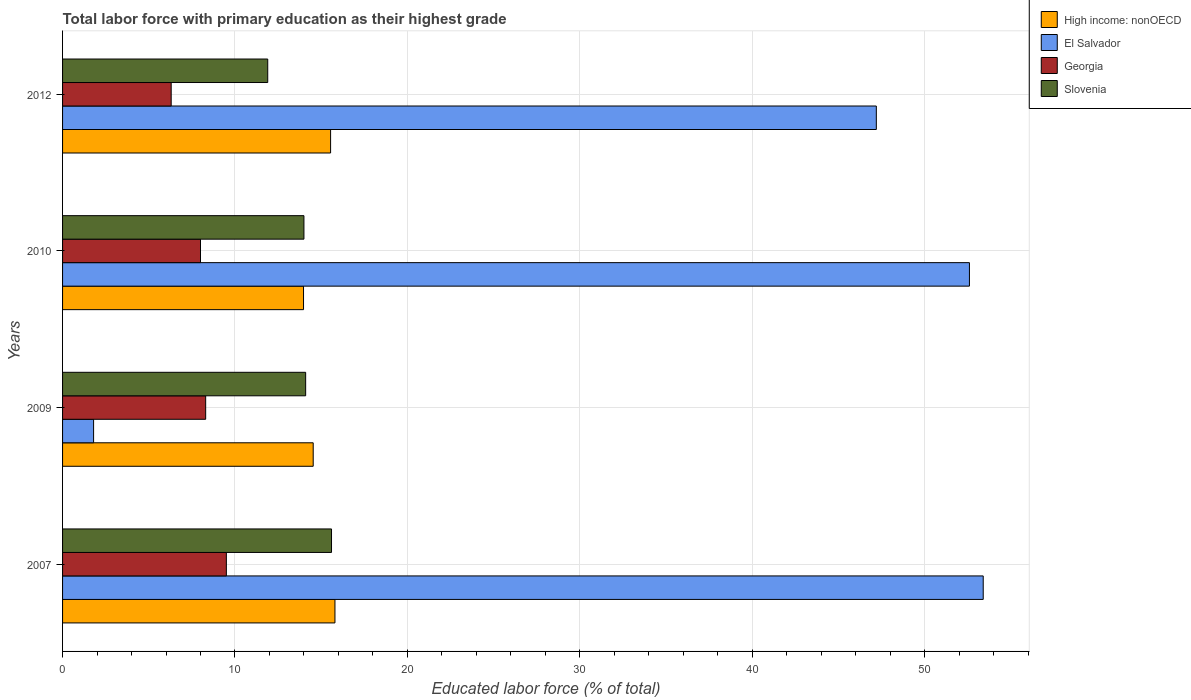How many groups of bars are there?
Provide a succinct answer. 4. Are the number of bars per tick equal to the number of legend labels?
Make the answer very short. Yes. How many bars are there on the 2nd tick from the top?
Offer a very short reply. 4. How many bars are there on the 3rd tick from the bottom?
Ensure brevity in your answer.  4. What is the label of the 4th group of bars from the top?
Ensure brevity in your answer.  2007. In how many cases, is the number of bars for a given year not equal to the number of legend labels?
Provide a short and direct response. 0. What is the percentage of total labor force with primary education in El Salvador in 2010?
Ensure brevity in your answer.  52.6. Across all years, what is the maximum percentage of total labor force with primary education in Slovenia?
Your response must be concise. 15.6. Across all years, what is the minimum percentage of total labor force with primary education in El Salvador?
Your answer should be very brief. 1.8. In which year was the percentage of total labor force with primary education in El Salvador minimum?
Make the answer very short. 2009. What is the total percentage of total labor force with primary education in Slovenia in the graph?
Your answer should be very brief. 55.6. What is the difference between the percentage of total labor force with primary education in High income: nonOECD in 2009 and that in 2010?
Make the answer very short. 0.56. What is the difference between the percentage of total labor force with primary education in High income: nonOECD in 2010 and the percentage of total labor force with primary education in Georgia in 2007?
Give a very brief answer. 4.48. What is the average percentage of total labor force with primary education in Slovenia per year?
Provide a short and direct response. 13.9. In the year 2009, what is the difference between the percentage of total labor force with primary education in Georgia and percentage of total labor force with primary education in El Salvador?
Keep it short and to the point. 6.5. What is the ratio of the percentage of total labor force with primary education in El Salvador in 2009 to that in 2010?
Provide a short and direct response. 0.03. Is the percentage of total labor force with primary education in Georgia in 2010 less than that in 2012?
Your answer should be compact. No. What is the difference between the highest and the second highest percentage of total labor force with primary education in High income: nonOECD?
Your answer should be compact. 0.25. What is the difference between the highest and the lowest percentage of total labor force with primary education in El Salvador?
Provide a short and direct response. 51.6. In how many years, is the percentage of total labor force with primary education in High income: nonOECD greater than the average percentage of total labor force with primary education in High income: nonOECD taken over all years?
Keep it short and to the point. 2. Is it the case that in every year, the sum of the percentage of total labor force with primary education in Slovenia and percentage of total labor force with primary education in Georgia is greater than the sum of percentage of total labor force with primary education in El Salvador and percentage of total labor force with primary education in High income: nonOECD?
Offer a very short reply. No. What does the 3rd bar from the top in 2007 represents?
Your answer should be compact. El Salvador. What does the 4th bar from the bottom in 2012 represents?
Your response must be concise. Slovenia. How many bars are there?
Provide a short and direct response. 16. Are all the bars in the graph horizontal?
Make the answer very short. Yes. Are the values on the major ticks of X-axis written in scientific E-notation?
Provide a succinct answer. No. Where does the legend appear in the graph?
Offer a terse response. Top right. How many legend labels are there?
Make the answer very short. 4. What is the title of the graph?
Your answer should be very brief. Total labor force with primary education as their highest grade. Does "Slovak Republic" appear as one of the legend labels in the graph?
Give a very brief answer. No. What is the label or title of the X-axis?
Your answer should be very brief. Educated labor force (% of total). What is the label or title of the Y-axis?
Offer a terse response. Years. What is the Educated labor force (% of total) in High income: nonOECD in 2007?
Your response must be concise. 15.8. What is the Educated labor force (% of total) in El Salvador in 2007?
Offer a terse response. 53.4. What is the Educated labor force (% of total) of Slovenia in 2007?
Ensure brevity in your answer.  15.6. What is the Educated labor force (% of total) of High income: nonOECD in 2009?
Your answer should be very brief. 14.54. What is the Educated labor force (% of total) in El Salvador in 2009?
Ensure brevity in your answer.  1.8. What is the Educated labor force (% of total) of Georgia in 2009?
Provide a short and direct response. 8.3. What is the Educated labor force (% of total) in Slovenia in 2009?
Keep it short and to the point. 14.1. What is the Educated labor force (% of total) of High income: nonOECD in 2010?
Ensure brevity in your answer.  13.98. What is the Educated labor force (% of total) in El Salvador in 2010?
Offer a terse response. 52.6. What is the Educated labor force (% of total) in Georgia in 2010?
Provide a short and direct response. 8. What is the Educated labor force (% of total) of High income: nonOECD in 2012?
Provide a succinct answer. 15.55. What is the Educated labor force (% of total) in El Salvador in 2012?
Ensure brevity in your answer.  47.2. What is the Educated labor force (% of total) of Georgia in 2012?
Offer a terse response. 6.3. What is the Educated labor force (% of total) in Slovenia in 2012?
Provide a succinct answer. 11.9. Across all years, what is the maximum Educated labor force (% of total) of High income: nonOECD?
Make the answer very short. 15.8. Across all years, what is the maximum Educated labor force (% of total) in El Salvador?
Your answer should be very brief. 53.4. Across all years, what is the maximum Educated labor force (% of total) of Slovenia?
Keep it short and to the point. 15.6. Across all years, what is the minimum Educated labor force (% of total) in High income: nonOECD?
Offer a very short reply. 13.98. Across all years, what is the minimum Educated labor force (% of total) in El Salvador?
Offer a very short reply. 1.8. Across all years, what is the minimum Educated labor force (% of total) in Georgia?
Provide a succinct answer. 6.3. Across all years, what is the minimum Educated labor force (% of total) of Slovenia?
Give a very brief answer. 11.9. What is the total Educated labor force (% of total) in High income: nonOECD in the graph?
Your answer should be very brief. 59.86. What is the total Educated labor force (% of total) in El Salvador in the graph?
Offer a terse response. 155. What is the total Educated labor force (% of total) of Georgia in the graph?
Provide a short and direct response. 32.1. What is the total Educated labor force (% of total) in Slovenia in the graph?
Give a very brief answer. 55.6. What is the difference between the Educated labor force (% of total) of High income: nonOECD in 2007 and that in 2009?
Provide a short and direct response. 1.26. What is the difference between the Educated labor force (% of total) in El Salvador in 2007 and that in 2009?
Provide a short and direct response. 51.6. What is the difference between the Educated labor force (% of total) in Slovenia in 2007 and that in 2009?
Ensure brevity in your answer.  1.5. What is the difference between the Educated labor force (% of total) of High income: nonOECD in 2007 and that in 2010?
Your answer should be very brief. 1.82. What is the difference between the Educated labor force (% of total) in Slovenia in 2007 and that in 2010?
Your answer should be very brief. 1.6. What is the difference between the Educated labor force (% of total) of High income: nonOECD in 2007 and that in 2012?
Ensure brevity in your answer.  0.25. What is the difference between the Educated labor force (% of total) in El Salvador in 2007 and that in 2012?
Keep it short and to the point. 6.2. What is the difference between the Educated labor force (% of total) of High income: nonOECD in 2009 and that in 2010?
Ensure brevity in your answer.  0.56. What is the difference between the Educated labor force (% of total) of El Salvador in 2009 and that in 2010?
Offer a very short reply. -50.8. What is the difference between the Educated labor force (% of total) of High income: nonOECD in 2009 and that in 2012?
Make the answer very short. -1.01. What is the difference between the Educated labor force (% of total) of El Salvador in 2009 and that in 2012?
Your answer should be compact. -45.4. What is the difference between the Educated labor force (% of total) in Georgia in 2009 and that in 2012?
Your answer should be compact. 2. What is the difference between the Educated labor force (% of total) of Slovenia in 2009 and that in 2012?
Give a very brief answer. 2.2. What is the difference between the Educated labor force (% of total) in High income: nonOECD in 2010 and that in 2012?
Offer a terse response. -1.57. What is the difference between the Educated labor force (% of total) of High income: nonOECD in 2007 and the Educated labor force (% of total) of El Salvador in 2009?
Your answer should be compact. 14. What is the difference between the Educated labor force (% of total) in High income: nonOECD in 2007 and the Educated labor force (% of total) in Georgia in 2009?
Your answer should be compact. 7.5. What is the difference between the Educated labor force (% of total) of High income: nonOECD in 2007 and the Educated labor force (% of total) of Slovenia in 2009?
Offer a terse response. 1.7. What is the difference between the Educated labor force (% of total) of El Salvador in 2007 and the Educated labor force (% of total) of Georgia in 2009?
Your response must be concise. 45.1. What is the difference between the Educated labor force (% of total) in El Salvador in 2007 and the Educated labor force (% of total) in Slovenia in 2009?
Ensure brevity in your answer.  39.3. What is the difference between the Educated labor force (% of total) of Georgia in 2007 and the Educated labor force (% of total) of Slovenia in 2009?
Offer a terse response. -4.6. What is the difference between the Educated labor force (% of total) of High income: nonOECD in 2007 and the Educated labor force (% of total) of El Salvador in 2010?
Your response must be concise. -36.8. What is the difference between the Educated labor force (% of total) of High income: nonOECD in 2007 and the Educated labor force (% of total) of Georgia in 2010?
Ensure brevity in your answer.  7.8. What is the difference between the Educated labor force (% of total) of High income: nonOECD in 2007 and the Educated labor force (% of total) of Slovenia in 2010?
Provide a short and direct response. 1.8. What is the difference between the Educated labor force (% of total) in El Salvador in 2007 and the Educated labor force (% of total) in Georgia in 2010?
Offer a very short reply. 45.4. What is the difference between the Educated labor force (% of total) in El Salvador in 2007 and the Educated labor force (% of total) in Slovenia in 2010?
Give a very brief answer. 39.4. What is the difference between the Educated labor force (% of total) in Georgia in 2007 and the Educated labor force (% of total) in Slovenia in 2010?
Ensure brevity in your answer.  -4.5. What is the difference between the Educated labor force (% of total) in High income: nonOECD in 2007 and the Educated labor force (% of total) in El Salvador in 2012?
Provide a short and direct response. -31.4. What is the difference between the Educated labor force (% of total) of High income: nonOECD in 2007 and the Educated labor force (% of total) of Georgia in 2012?
Your answer should be very brief. 9.5. What is the difference between the Educated labor force (% of total) in High income: nonOECD in 2007 and the Educated labor force (% of total) in Slovenia in 2012?
Offer a terse response. 3.9. What is the difference between the Educated labor force (% of total) in El Salvador in 2007 and the Educated labor force (% of total) in Georgia in 2012?
Provide a short and direct response. 47.1. What is the difference between the Educated labor force (% of total) of El Salvador in 2007 and the Educated labor force (% of total) of Slovenia in 2012?
Keep it short and to the point. 41.5. What is the difference between the Educated labor force (% of total) in Georgia in 2007 and the Educated labor force (% of total) in Slovenia in 2012?
Your response must be concise. -2.4. What is the difference between the Educated labor force (% of total) in High income: nonOECD in 2009 and the Educated labor force (% of total) in El Salvador in 2010?
Ensure brevity in your answer.  -38.06. What is the difference between the Educated labor force (% of total) of High income: nonOECD in 2009 and the Educated labor force (% of total) of Georgia in 2010?
Offer a terse response. 6.54. What is the difference between the Educated labor force (% of total) of High income: nonOECD in 2009 and the Educated labor force (% of total) of Slovenia in 2010?
Keep it short and to the point. 0.54. What is the difference between the Educated labor force (% of total) of El Salvador in 2009 and the Educated labor force (% of total) of Slovenia in 2010?
Keep it short and to the point. -12.2. What is the difference between the Educated labor force (% of total) of Georgia in 2009 and the Educated labor force (% of total) of Slovenia in 2010?
Ensure brevity in your answer.  -5.7. What is the difference between the Educated labor force (% of total) of High income: nonOECD in 2009 and the Educated labor force (% of total) of El Salvador in 2012?
Offer a very short reply. -32.66. What is the difference between the Educated labor force (% of total) in High income: nonOECD in 2009 and the Educated labor force (% of total) in Georgia in 2012?
Offer a terse response. 8.24. What is the difference between the Educated labor force (% of total) in High income: nonOECD in 2009 and the Educated labor force (% of total) in Slovenia in 2012?
Your response must be concise. 2.64. What is the difference between the Educated labor force (% of total) of High income: nonOECD in 2010 and the Educated labor force (% of total) of El Salvador in 2012?
Provide a short and direct response. -33.22. What is the difference between the Educated labor force (% of total) of High income: nonOECD in 2010 and the Educated labor force (% of total) of Georgia in 2012?
Your answer should be compact. 7.68. What is the difference between the Educated labor force (% of total) of High income: nonOECD in 2010 and the Educated labor force (% of total) of Slovenia in 2012?
Your answer should be compact. 2.08. What is the difference between the Educated labor force (% of total) of El Salvador in 2010 and the Educated labor force (% of total) of Georgia in 2012?
Provide a succinct answer. 46.3. What is the difference between the Educated labor force (% of total) of El Salvador in 2010 and the Educated labor force (% of total) of Slovenia in 2012?
Provide a succinct answer. 40.7. What is the difference between the Educated labor force (% of total) in Georgia in 2010 and the Educated labor force (% of total) in Slovenia in 2012?
Ensure brevity in your answer.  -3.9. What is the average Educated labor force (% of total) in High income: nonOECD per year?
Make the answer very short. 14.96. What is the average Educated labor force (% of total) in El Salvador per year?
Your answer should be compact. 38.75. What is the average Educated labor force (% of total) in Georgia per year?
Provide a succinct answer. 8.03. What is the average Educated labor force (% of total) of Slovenia per year?
Your answer should be compact. 13.9. In the year 2007, what is the difference between the Educated labor force (% of total) of High income: nonOECD and Educated labor force (% of total) of El Salvador?
Your answer should be compact. -37.6. In the year 2007, what is the difference between the Educated labor force (% of total) of High income: nonOECD and Educated labor force (% of total) of Georgia?
Make the answer very short. 6.3. In the year 2007, what is the difference between the Educated labor force (% of total) of High income: nonOECD and Educated labor force (% of total) of Slovenia?
Keep it short and to the point. 0.2. In the year 2007, what is the difference between the Educated labor force (% of total) of El Salvador and Educated labor force (% of total) of Georgia?
Make the answer very short. 43.9. In the year 2007, what is the difference between the Educated labor force (% of total) of El Salvador and Educated labor force (% of total) of Slovenia?
Offer a terse response. 37.8. In the year 2009, what is the difference between the Educated labor force (% of total) in High income: nonOECD and Educated labor force (% of total) in El Salvador?
Ensure brevity in your answer.  12.74. In the year 2009, what is the difference between the Educated labor force (% of total) of High income: nonOECD and Educated labor force (% of total) of Georgia?
Your response must be concise. 6.24. In the year 2009, what is the difference between the Educated labor force (% of total) in High income: nonOECD and Educated labor force (% of total) in Slovenia?
Give a very brief answer. 0.44. In the year 2009, what is the difference between the Educated labor force (% of total) in El Salvador and Educated labor force (% of total) in Slovenia?
Offer a very short reply. -12.3. In the year 2010, what is the difference between the Educated labor force (% of total) of High income: nonOECD and Educated labor force (% of total) of El Salvador?
Offer a very short reply. -38.62. In the year 2010, what is the difference between the Educated labor force (% of total) in High income: nonOECD and Educated labor force (% of total) in Georgia?
Offer a terse response. 5.98. In the year 2010, what is the difference between the Educated labor force (% of total) of High income: nonOECD and Educated labor force (% of total) of Slovenia?
Your answer should be very brief. -0.02. In the year 2010, what is the difference between the Educated labor force (% of total) of El Salvador and Educated labor force (% of total) of Georgia?
Your answer should be very brief. 44.6. In the year 2010, what is the difference between the Educated labor force (% of total) of El Salvador and Educated labor force (% of total) of Slovenia?
Your answer should be very brief. 38.6. In the year 2010, what is the difference between the Educated labor force (% of total) in Georgia and Educated labor force (% of total) in Slovenia?
Provide a short and direct response. -6. In the year 2012, what is the difference between the Educated labor force (% of total) in High income: nonOECD and Educated labor force (% of total) in El Salvador?
Offer a very short reply. -31.65. In the year 2012, what is the difference between the Educated labor force (% of total) in High income: nonOECD and Educated labor force (% of total) in Georgia?
Your answer should be compact. 9.25. In the year 2012, what is the difference between the Educated labor force (% of total) in High income: nonOECD and Educated labor force (% of total) in Slovenia?
Offer a very short reply. 3.65. In the year 2012, what is the difference between the Educated labor force (% of total) of El Salvador and Educated labor force (% of total) of Georgia?
Your answer should be very brief. 40.9. In the year 2012, what is the difference between the Educated labor force (% of total) of El Salvador and Educated labor force (% of total) of Slovenia?
Offer a terse response. 35.3. What is the ratio of the Educated labor force (% of total) in High income: nonOECD in 2007 to that in 2009?
Ensure brevity in your answer.  1.09. What is the ratio of the Educated labor force (% of total) of El Salvador in 2007 to that in 2009?
Give a very brief answer. 29.67. What is the ratio of the Educated labor force (% of total) in Georgia in 2007 to that in 2009?
Your answer should be very brief. 1.14. What is the ratio of the Educated labor force (% of total) in Slovenia in 2007 to that in 2009?
Keep it short and to the point. 1.11. What is the ratio of the Educated labor force (% of total) of High income: nonOECD in 2007 to that in 2010?
Your answer should be very brief. 1.13. What is the ratio of the Educated labor force (% of total) in El Salvador in 2007 to that in 2010?
Your answer should be very brief. 1.02. What is the ratio of the Educated labor force (% of total) of Georgia in 2007 to that in 2010?
Your response must be concise. 1.19. What is the ratio of the Educated labor force (% of total) of Slovenia in 2007 to that in 2010?
Provide a short and direct response. 1.11. What is the ratio of the Educated labor force (% of total) in High income: nonOECD in 2007 to that in 2012?
Offer a terse response. 1.02. What is the ratio of the Educated labor force (% of total) in El Salvador in 2007 to that in 2012?
Your answer should be compact. 1.13. What is the ratio of the Educated labor force (% of total) of Georgia in 2007 to that in 2012?
Ensure brevity in your answer.  1.51. What is the ratio of the Educated labor force (% of total) of Slovenia in 2007 to that in 2012?
Your answer should be compact. 1.31. What is the ratio of the Educated labor force (% of total) of High income: nonOECD in 2009 to that in 2010?
Offer a terse response. 1.04. What is the ratio of the Educated labor force (% of total) of El Salvador in 2009 to that in 2010?
Provide a succinct answer. 0.03. What is the ratio of the Educated labor force (% of total) in Georgia in 2009 to that in 2010?
Provide a succinct answer. 1.04. What is the ratio of the Educated labor force (% of total) in Slovenia in 2009 to that in 2010?
Provide a short and direct response. 1.01. What is the ratio of the Educated labor force (% of total) of High income: nonOECD in 2009 to that in 2012?
Your answer should be compact. 0.94. What is the ratio of the Educated labor force (% of total) of El Salvador in 2009 to that in 2012?
Provide a succinct answer. 0.04. What is the ratio of the Educated labor force (% of total) in Georgia in 2009 to that in 2012?
Your response must be concise. 1.32. What is the ratio of the Educated labor force (% of total) of Slovenia in 2009 to that in 2012?
Offer a terse response. 1.18. What is the ratio of the Educated labor force (% of total) in High income: nonOECD in 2010 to that in 2012?
Offer a very short reply. 0.9. What is the ratio of the Educated labor force (% of total) in El Salvador in 2010 to that in 2012?
Provide a succinct answer. 1.11. What is the ratio of the Educated labor force (% of total) in Georgia in 2010 to that in 2012?
Your answer should be very brief. 1.27. What is the ratio of the Educated labor force (% of total) in Slovenia in 2010 to that in 2012?
Keep it short and to the point. 1.18. What is the difference between the highest and the second highest Educated labor force (% of total) in High income: nonOECD?
Your response must be concise. 0.25. What is the difference between the highest and the second highest Educated labor force (% of total) in Slovenia?
Provide a succinct answer. 1.5. What is the difference between the highest and the lowest Educated labor force (% of total) in High income: nonOECD?
Your answer should be very brief. 1.82. What is the difference between the highest and the lowest Educated labor force (% of total) of El Salvador?
Your response must be concise. 51.6. What is the difference between the highest and the lowest Educated labor force (% of total) of Georgia?
Provide a short and direct response. 3.2. 